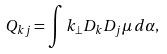<formula> <loc_0><loc_0><loc_500><loc_500>Q _ { k j } = \int k _ { \bot } D _ { k } D _ { j } \mu \, d \alpha ,</formula> 